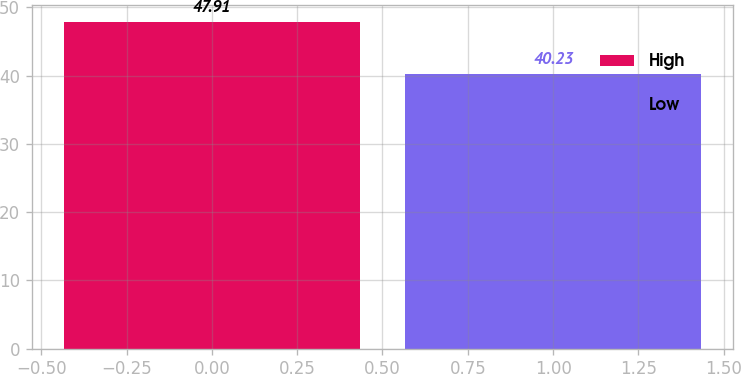<chart> <loc_0><loc_0><loc_500><loc_500><bar_chart><fcel>High<fcel>Low<nl><fcel>47.91<fcel>40.23<nl></chart> 